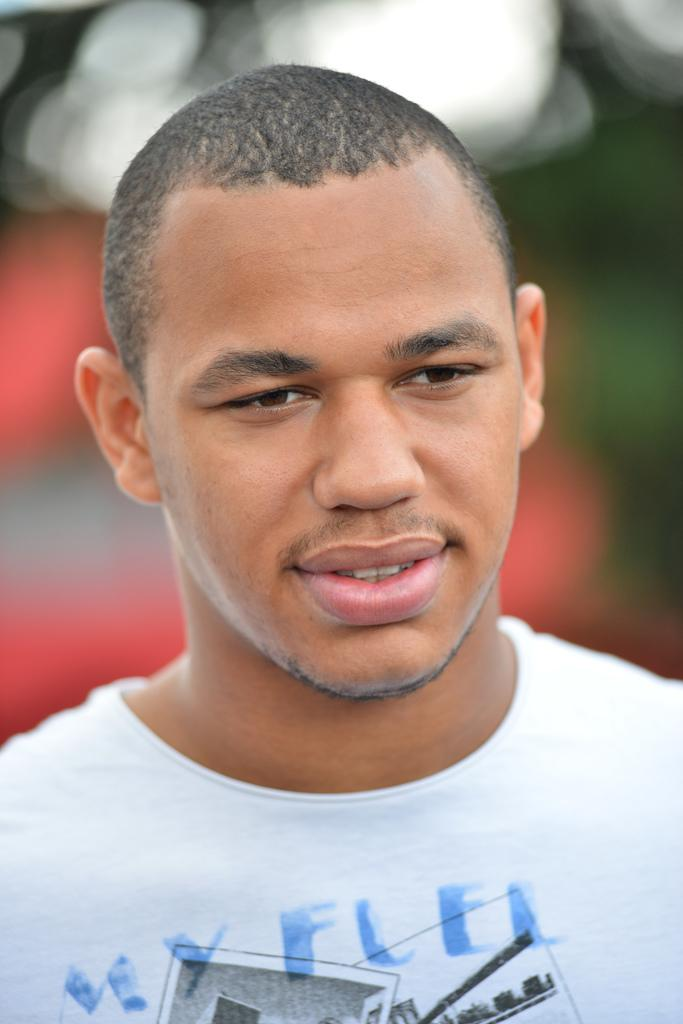What is the main subject of the image? There is a person in the image. What is the person wearing in the image? The person is wearing a white shirt. What is the person doing in the image? The person is posing for a picture. What type of kitten can be seen on the person's wrist in the image? There is no kitten present on the person's wrist in the image. What time does the watch on the person's wrist display in the image? There is no watch visible on the person's wrist in the image. 